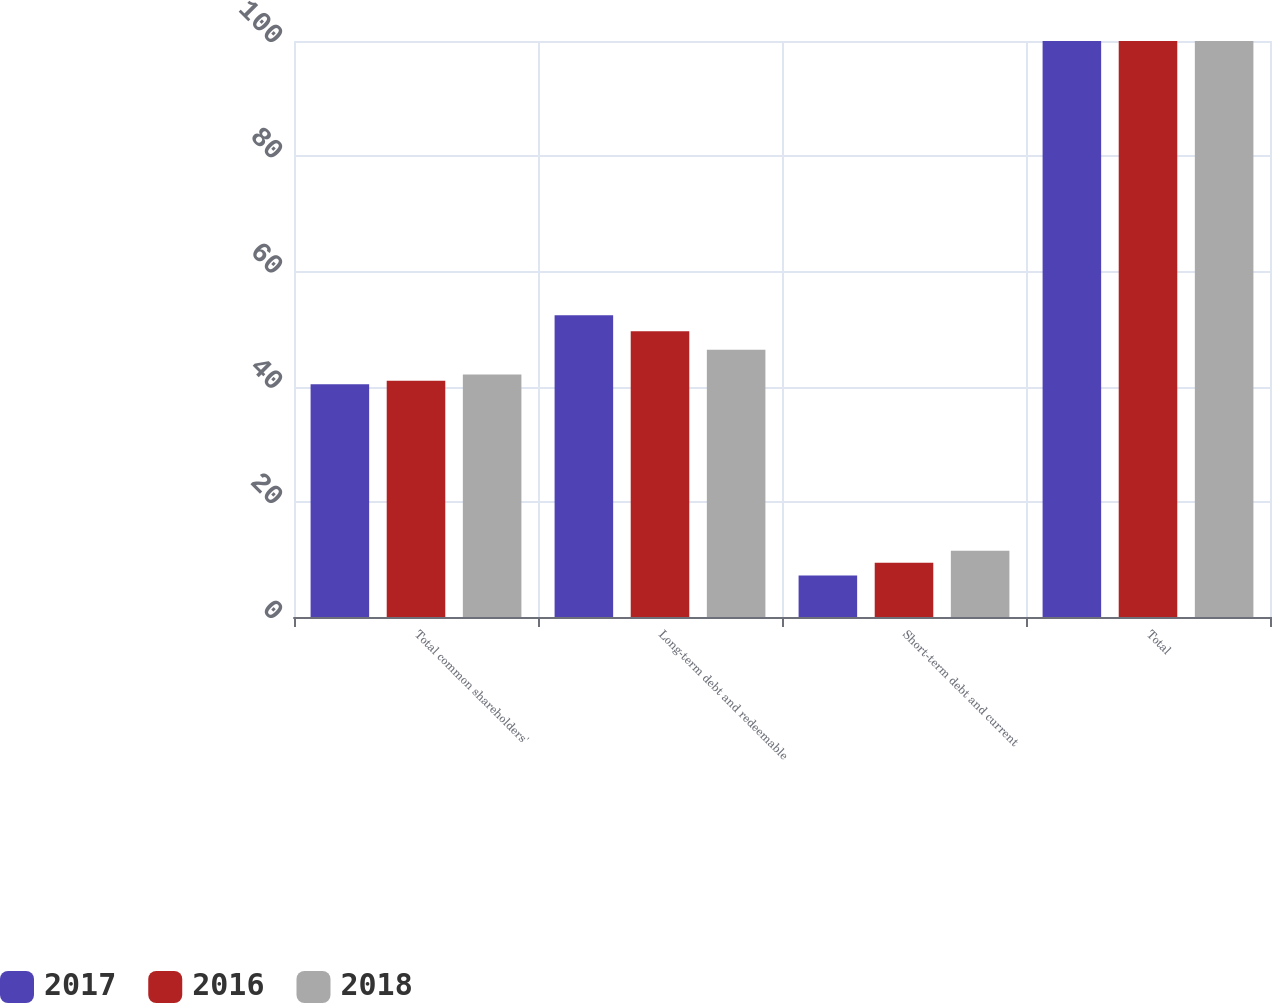Convert chart. <chart><loc_0><loc_0><loc_500><loc_500><stacked_bar_chart><ecel><fcel>Total common shareholders'<fcel>Long-term debt and redeemable<fcel>Short-term debt and current<fcel>Total<nl><fcel>2017<fcel>40.4<fcel>52.4<fcel>7.2<fcel>100<nl><fcel>2016<fcel>41<fcel>49.6<fcel>9.4<fcel>100<nl><fcel>2018<fcel>42.1<fcel>46.4<fcel>11.5<fcel>100<nl></chart> 